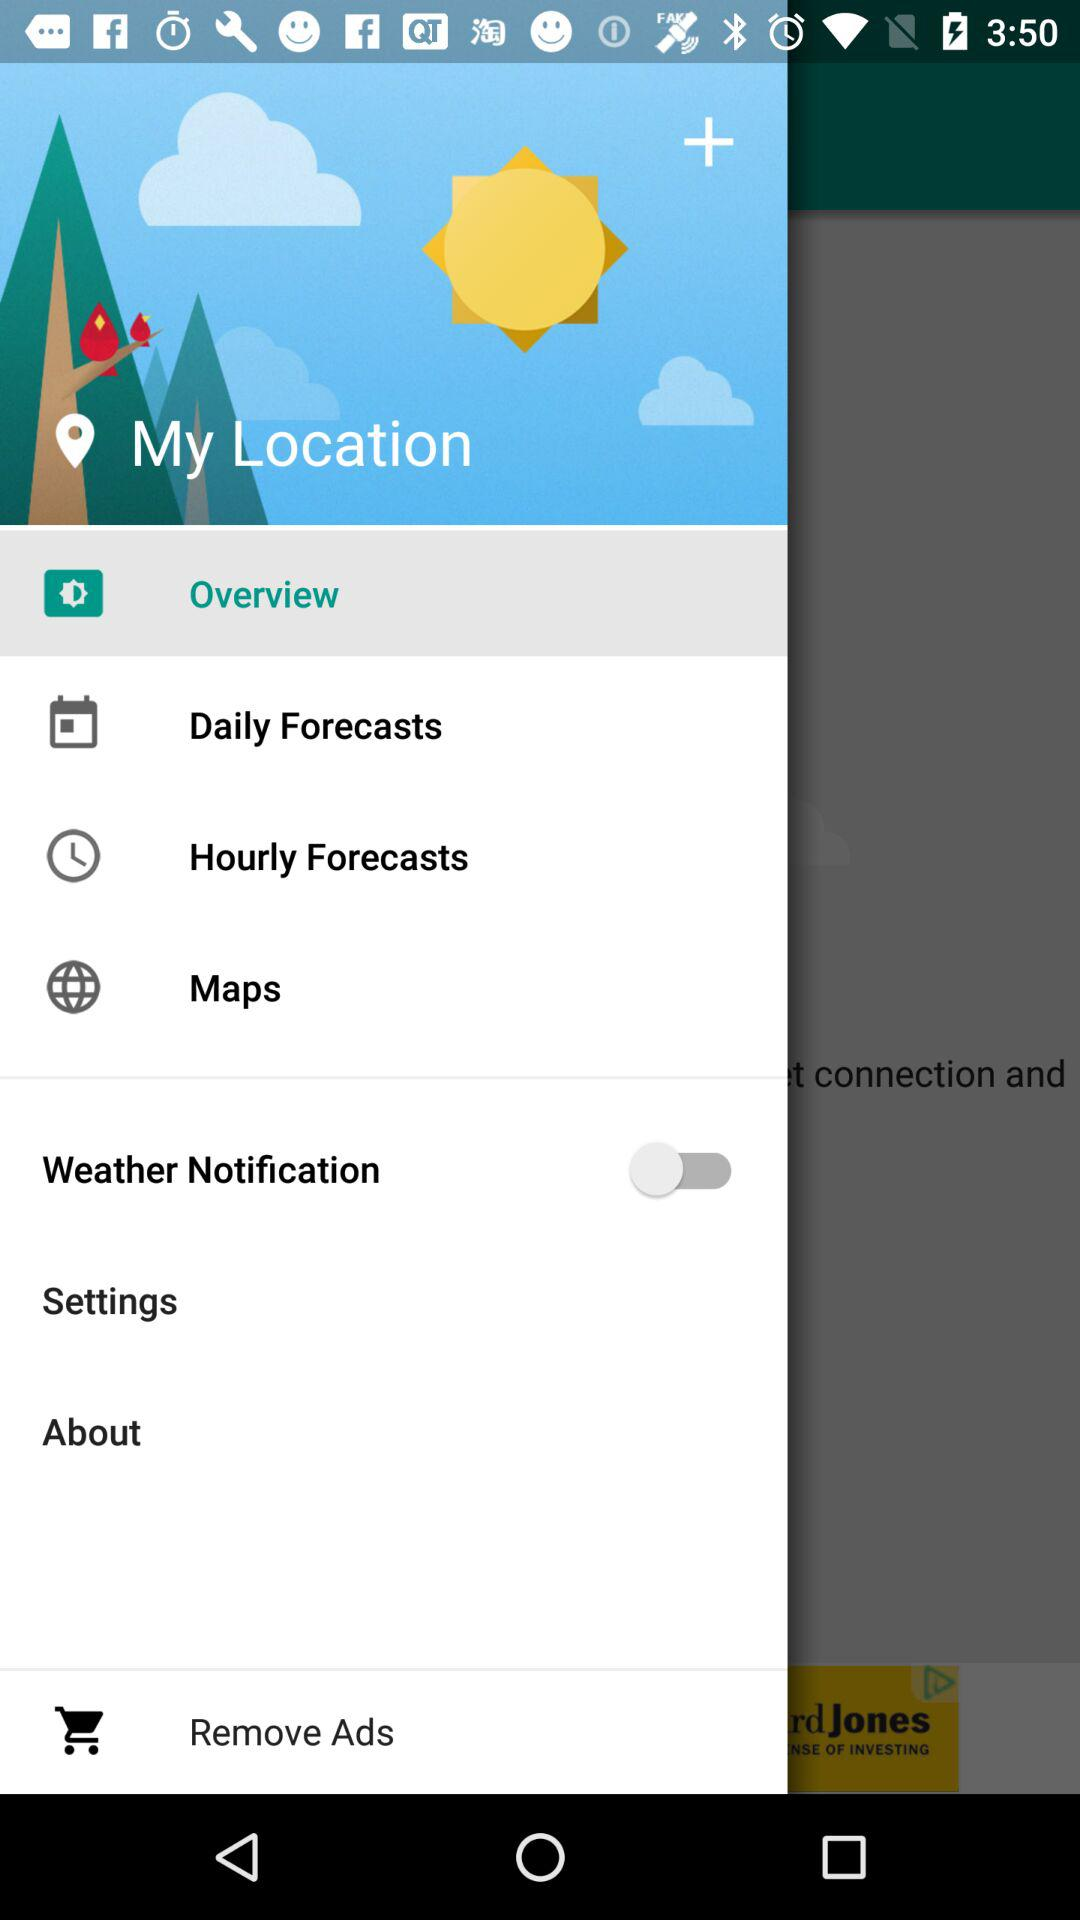What is the status of "Weather Notification"? The status of "Weather Notification" is "off". 